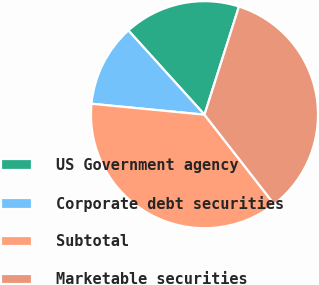Convert chart. <chart><loc_0><loc_0><loc_500><loc_500><pie_chart><fcel>US Government agency<fcel>Corporate debt securities<fcel>Subtotal<fcel>Marketable securities<nl><fcel>16.61%<fcel>11.77%<fcel>37.07%<fcel>34.56%<nl></chart> 